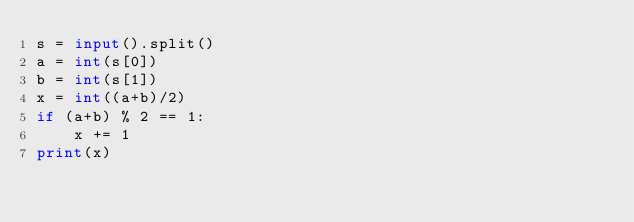<code> <loc_0><loc_0><loc_500><loc_500><_Python_>s = input().split()
a = int(s[0])
b = int(s[1])
x = int((a+b)/2)
if (a+b) % 2 == 1:
    x += 1
print(x)</code> 